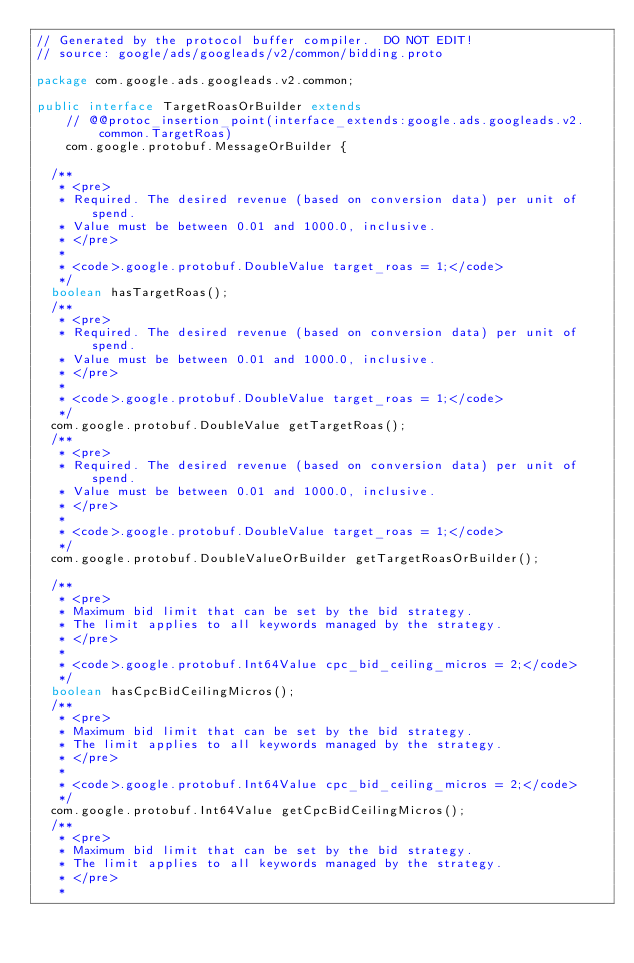<code> <loc_0><loc_0><loc_500><loc_500><_Java_>// Generated by the protocol buffer compiler.  DO NOT EDIT!
// source: google/ads/googleads/v2/common/bidding.proto

package com.google.ads.googleads.v2.common;

public interface TargetRoasOrBuilder extends
    // @@protoc_insertion_point(interface_extends:google.ads.googleads.v2.common.TargetRoas)
    com.google.protobuf.MessageOrBuilder {

  /**
   * <pre>
   * Required. The desired revenue (based on conversion data) per unit of spend.
   * Value must be between 0.01 and 1000.0, inclusive.
   * </pre>
   *
   * <code>.google.protobuf.DoubleValue target_roas = 1;</code>
   */
  boolean hasTargetRoas();
  /**
   * <pre>
   * Required. The desired revenue (based on conversion data) per unit of spend.
   * Value must be between 0.01 and 1000.0, inclusive.
   * </pre>
   *
   * <code>.google.protobuf.DoubleValue target_roas = 1;</code>
   */
  com.google.protobuf.DoubleValue getTargetRoas();
  /**
   * <pre>
   * Required. The desired revenue (based on conversion data) per unit of spend.
   * Value must be between 0.01 and 1000.0, inclusive.
   * </pre>
   *
   * <code>.google.protobuf.DoubleValue target_roas = 1;</code>
   */
  com.google.protobuf.DoubleValueOrBuilder getTargetRoasOrBuilder();

  /**
   * <pre>
   * Maximum bid limit that can be set by the bid strategy.
   * The limit applies to all keywords managed by the strategy.
   * </pre>
   *
   * <code>.google.protobuf.Int64Value cpc_bid_ceiling_micros = 2;</code>
   */
  boolean hasCpcBidCeilingMicros();
  /**
   * <pre>
   * Maximum bid limit that can be set by the bid strategy.
   * The limit applies to all keywords managed by the strategy.
   * </pre>
   *
   * <code>.google.protobuf.Int64Value cpc_bid_ceiling_micros = 2;</code>
   */
  com.google.protobuf.Int64Value getCpcBidCeilingMicros();
  /**
   * <pre>
   * Maximum bid limit that can be set by the bid strategy.
   * The limit applies to all keywords managed by the strategy.
   * </pre>
   *</code> 